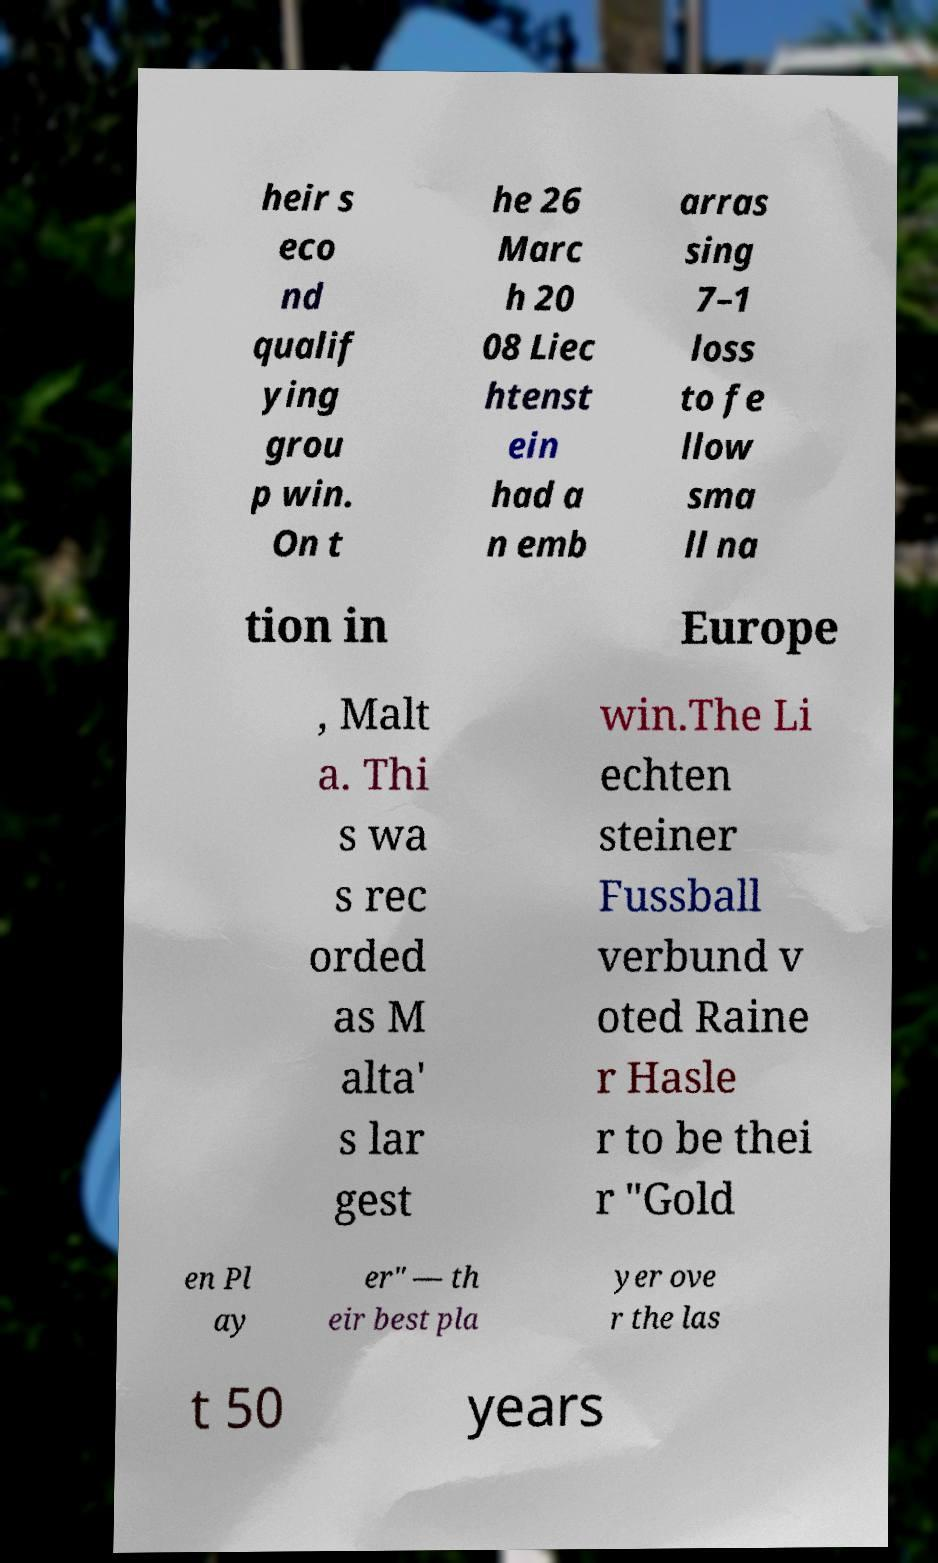There's text embedded in this image that I need extracted. Can you transcribe it verbatim? heir s eco nd qualif ying grou p win. On t he 26 Marc h 20 08 Liec htenst ein had a n emb arras sing 7–1 loss to fe llow sma ll na tion in Europe , Malt a. Thi s wa s rec orded as M alta' s lar gest win.The Li echten steiner Fussball verbund v oted Raine r Hasle r to be thei r "Gold en Pl ay er" — th eir best pla yer ove r the las t 50 years 